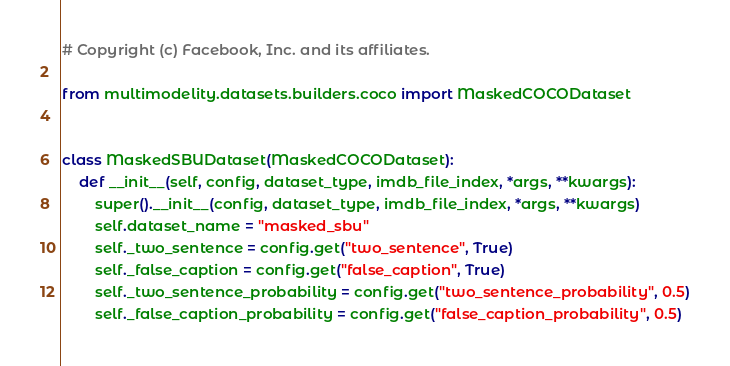Convert code to text. <code><loc_0><loc_0><loc_500><loc_500><_Python_># Copyright (c) Facebook, Inc. and its affiliates.

from multimodelity.datasets.builders.coco import MaskedCOCODataset


class MaskedSBUDataset(MaskedCOCODataset):
    def __init__(self, config, dataset_type, imdb_file_index, *args, **kwargs):
        super().__init__(config, dataset_type, imdb_file_index, *args, **kwargs)
        self.dataset_name = "masked_sbu"
        self._two_sentence = config.get("two_sentence", True)
        self._false_caption = config.get("false_caption", True)
        self._two_sentence_probability = config.get("two_sentence_probability", 0.5)
        self._false_caption_probability = config.get("false_caption_probability", 0.5)
</code> 